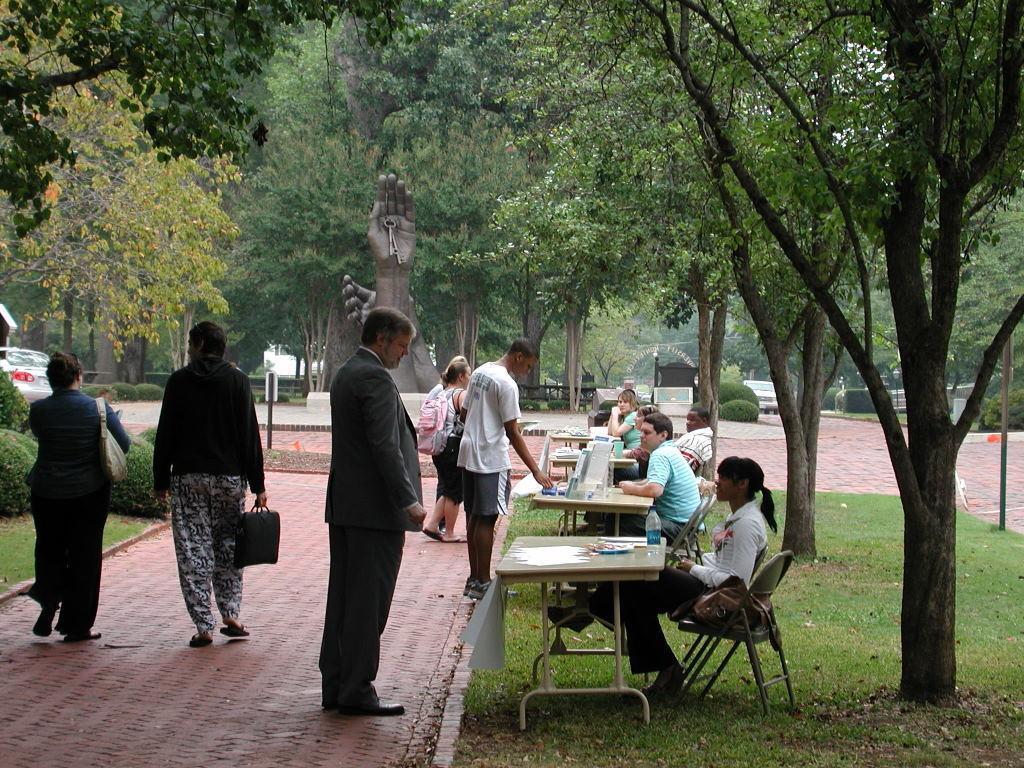How would you summarize this image in a sentence or two? In this image I see number of people in which most of them are sitting on the chairs and there are tables in front of them on which there are few things and few of them are on the path. In the background IN the grass, plants, trees, a statue and a car over here. 